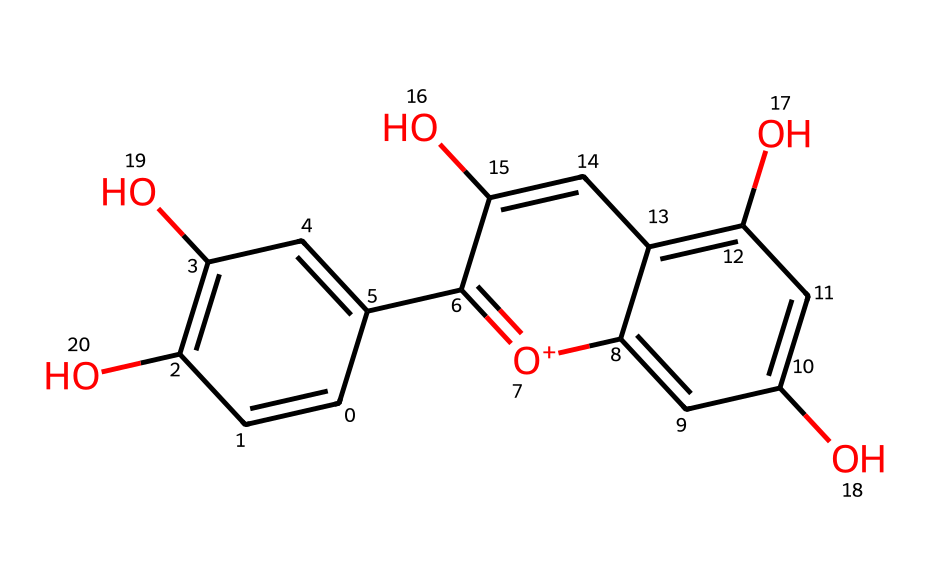What is the molecular formula of this compound? By counting the atoms represented in the SMILES notation, we can identify that there are 15 carbon atoms (C), 11 hydrogen atoms (H), and 6 oxygen atoms (O), leading to the molecular formula C15H11O6.
Answer: C15H11O6 How many hydroxyl (–OH) groups are present in this molecule? The structure contains multiple –OH groups, which are indicated by 'O' followed by a connection to a carbon atom in the SMILES representation. Counting reveals there are 4 hydroxyl groups present.
Answer: 4 What type of chemical is this compound classified as? Based on its structure, which features a polyphenolic framework and multiple hydroxyl groups, this compound is classified as a flavonoid.
Answer: flavonoid How many double bonds are in the chemical structure? In the SMILES representation, double bonds are marked by the '=' character. Counting these characters indicates there are 6 double bonds in total within the compound.
Answer: 6 What is the role of anthocyanins in biological systems? Anthocyanins, such as the one represented by this structure, primarily act as antioxidants, helping to protect cells from oxidative damage in biological systems.
Answer: antioxidants What colors do anthocyanins typically contribute to in fruits? The presence of anthocyanins in fruits is predominantly associated with red, purple, and blue colors, as these pigments reflect and transmit light in the visible spectrum.
Answer: red, purple, blue How many aromatic rings are present in the structure? Upon visual evaluation of the SMILES and the described structure, there are two distinct aromatic rings, commonly characterized by alternating double bonds (the 'C' atoms in the structure).
Answer: 2 